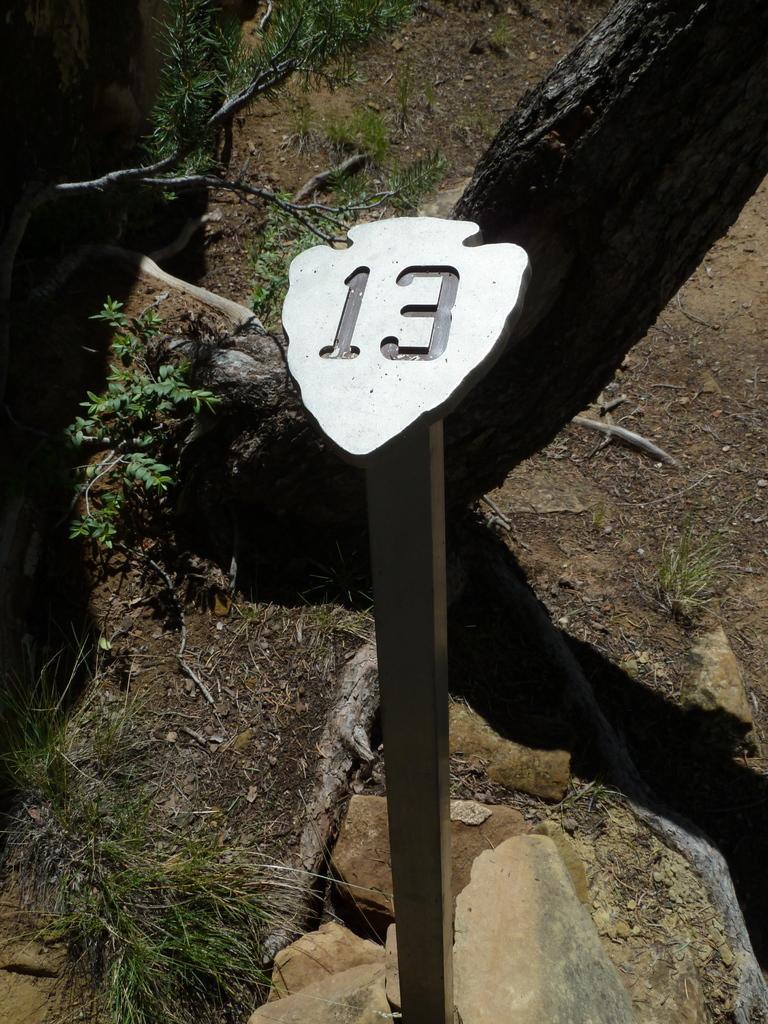Describe this image in one or two sentences. In the center of the image there is a pole. In the background there are rocks and we can see grass. 